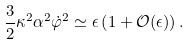<formula> <loc_0><loc_0><loc_500><loc_500>\frac { 3 } { 2 } \kappa ^ { 2 } \alpha ^ { 2 } \dot { \varphi } ^ { 2 } \simeq \epsilon \left ( 1 + \mathcal { O } ( \epsilon ) \right ) .</formula> 